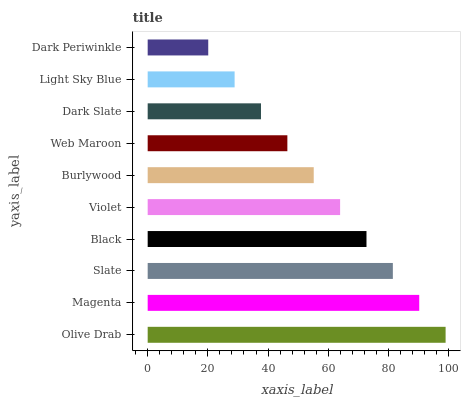Is Dark Periwinkle the minimum?
Answer yes or no. Yes. Is Olive Drab the maximum?
Answer yes or no. Yes. Is Magenta the minimum?
Answer yes or no. No. Is Magenta the maximum?
Answer yes or no. No. Is Olive Drab greater than Magenta?
Answer yes or no. Yes. Is Magenta less than Olive Drab?
Answer yes or no. Yes. Is Magenta greater than Olive Drab?
Answer yes or no. No. Is Olive Drab less than Magenta?
Answer yes or no. No. Is Violet the high median?
Answer yes or no. Yes. Is Burlywood the low median?
Answer yes or no. Yes. Is Dark Periwinkle the high median?
Answer yes or no. No. Is Violet the low median?
Answer yes or no. No. 